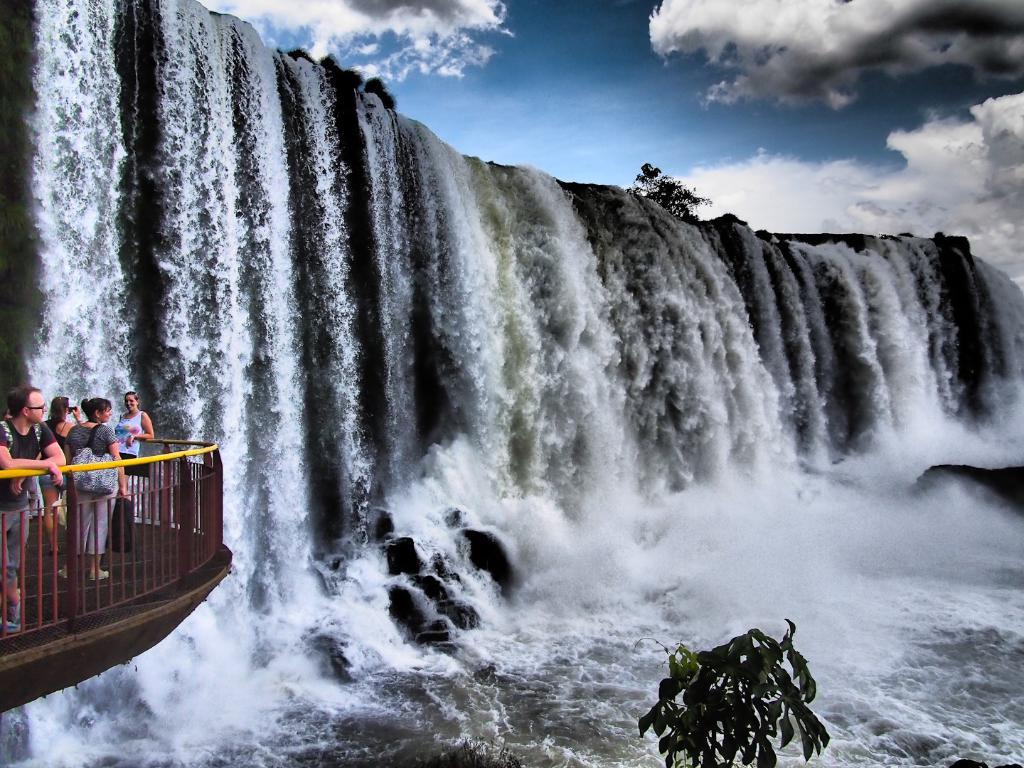What natural feature is the main subject of the image? There is a waterfall in the image. What man-made structure is located near the waterfall? There is a bridge beside the waterfall. Who can be seen in the image? Tourists are present inside the bridge. What are the tourists doing in the image? The tourists are enjoying the beautiful view. What type of apparatus is being used by the tourists to capture the view? There is no specific apparatus mentioned in the image, but the tourists might be using cameras or smartphones to capture the view. Is there a box containing souvenirs near the waterfall? There is no mention of a box containing souvenirs in the image. 